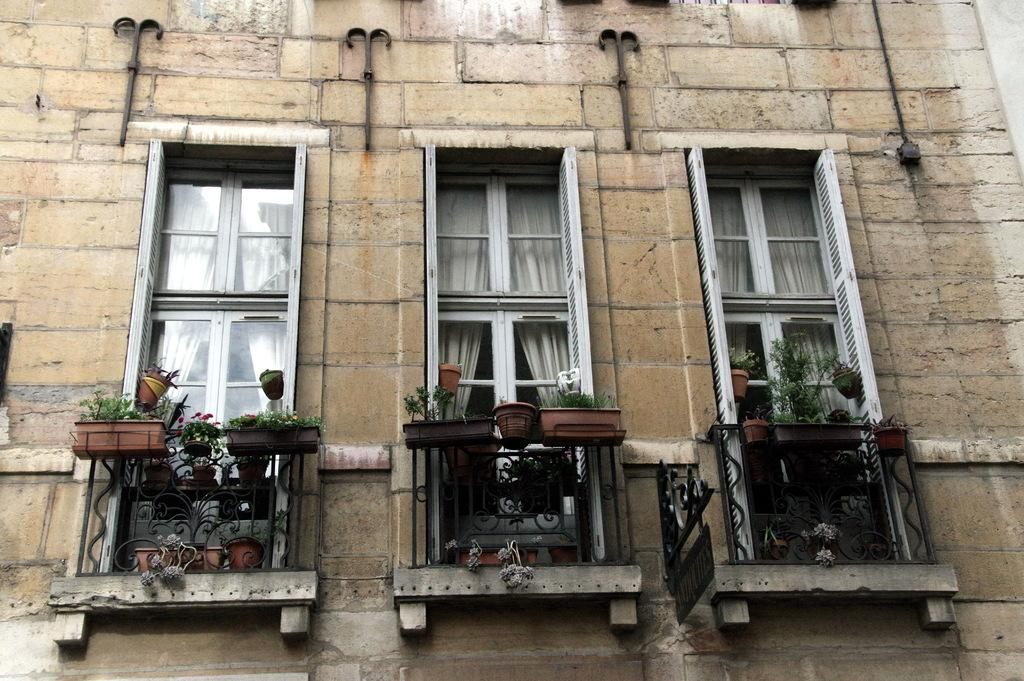What is the main structure visible in the picture? There is a building in the picture. What can be seen behind the windows of the building? There are curtains behind the windows of the building. What type of decorative or functional elements are present on the building? There are plants on the railing and behind the railing of the building. What type of badge is visible on the minute hand of the clock on the building? There is no clock or badge present on the building in the image. What type of tank is visible near the plants on the railing of the building? There is no tank present near the plants on the railing of the building in the image. 